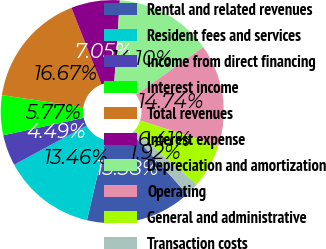Convert chart to OTSL. <chart><loc_0><loc_0><loc_500><loc_500><pie_chart><fcel>Rental and related revenues<fcel>Resident fees and services<fcel>Income from direct financing<fcel>Interest income<fcel>Total revenues<fcel>Interest expense<fcel>Depreciation and amortization<fcel>Operating<fcel>General and administrative<fcel>Transaction costs<nl><fcel>15.38%<fcel>13.46%<fcel>4.49%<fcel>5.77%<fcel>16.67%<fcel>7.05%<fcel>14.1%<fcel>14.74%<fcel>6.41%<fcel>1.92%<nl></chart> 